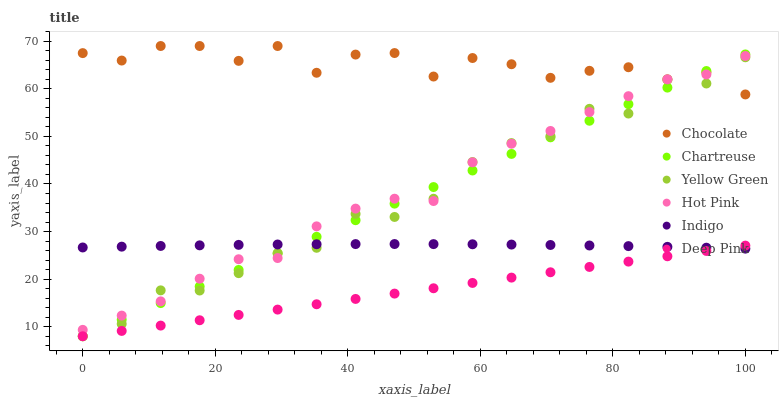Does Deep Pink have the minimum area under the curve?
Answer yes or no. Yes. Does Chocolate have the maximum area under the curve?
Answer yes or no. Yes. Does Indigo have the minimum area under the curve?
Answer yes or no. No. Does Indigo have the maximum area under the curve?
Answer yes or no. No. Is Deep Pink the smoothest?
Answer yes or no. Yes. Is Yellow Green the roughest?
Answer yes or no. Yes. Is Indigo the smoothest?
Answer yes or no. No. Is Indigo the roughest?
Answer yes or no. No. Does Deep Pink have the lowest value?
Answer yes or no. Yes. Does Indigo have the lowest value?
Answer yes or no. No. Does Chocolate have the highest value?
Answer yes or no. Yes. Does Indigo have the highest value?
Answer yes or no. No. Is Deep Pink less than Hot Pink?
Answer yes or no. Yes. Is Chocolate greater than Indigo?
Answer yes or no. Yes. Does Chartreuse intersect Indigo?
Answer yes or no. Yes. Is Chartreuse less than Indigo?
Answer yes or no. No. Is Chartreuse greater than Indigo?
Answer yes or no. No. Does Deep Pink intersect Hot Pink?
Answer yes or no. No. 